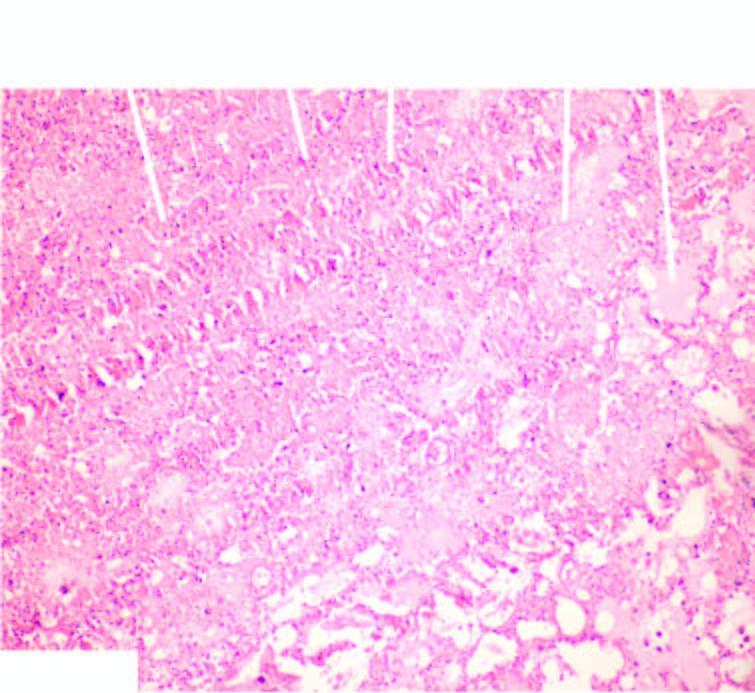does the necrosed area on right side of the field show ghostal veoli filled with blood?
Answer the question using a single word or phrase. No 